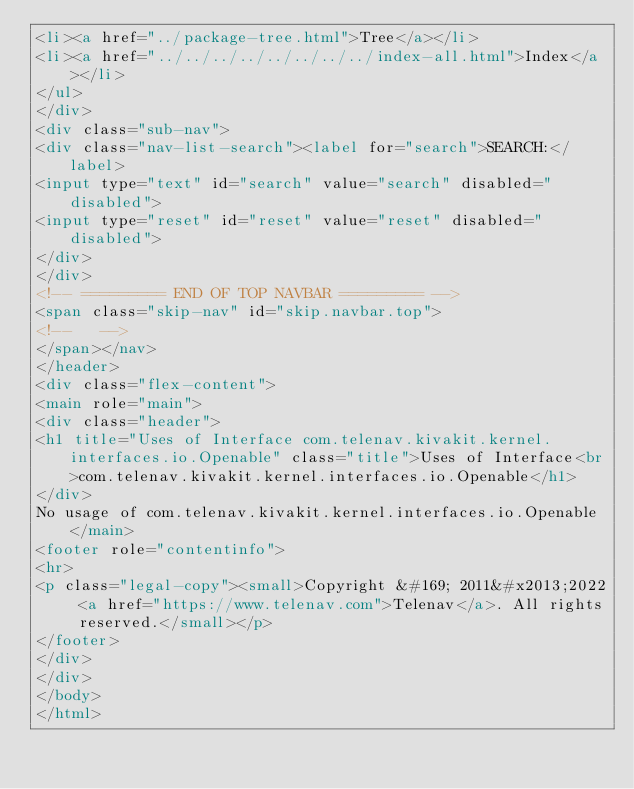Convert code to text. <code><loc_0><loc_0><loc_500><loc_500><_HTML_><li><a href="../package-tree.html">Tree</a></li>
<li><a href="../../../../../../../../index-all.html">Index</a></li>
</ul>
</div>
<div class="sub-nav">
<div class="nav-list-search"><label for="search">SEARCH:</label>
<input type="text" id="search" value="search" disabled="disabled">
<input type="reset" id="reset" value="reset" disabled="disabled">
</div>
</div>
<!-- ========= END OF TOP NAVBAR ========= -->
<span class="skip-nav" id="skip.navbar.top">
<!--   -->
</span></nav>
</header>
<div class="flex-content">
<main role="main">
<div class="header">
<h1 title="Uses of Interface com.telenav.kivakit.kernel.interfaces.io.Openable" class="title">Uses of Interface<br>com.telenav.kivakit.kernel.interfaces.io.Openable</h1>
</div>
No usage of com.telenav.kivakit.kernel.interfaces.io.Openable</main>
<footer role="contentinfo">
<hr>
<p class="legal-copy"><small>Copyright &#169; 2011&#x2013;2022 <a href="https://www.telenav.com">Telenav</a>. All rights reserved.</small></p>
</footer>
</div>
</div>
</body>
</html>
</code> 